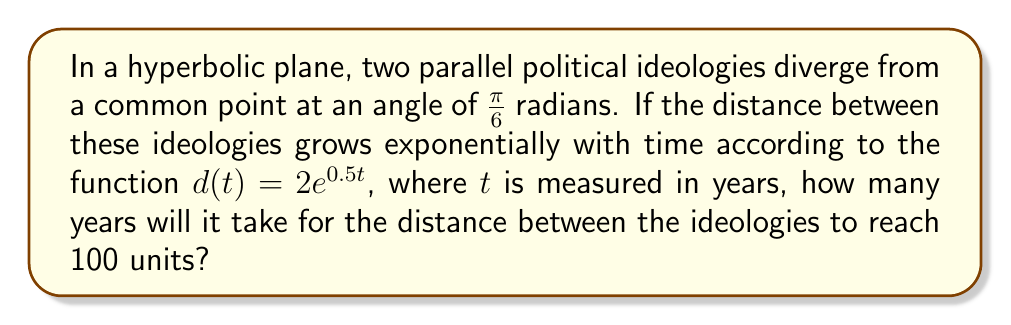Show me your answer to this math problem. Let's approach this step-by-step:

1) In hyperbolic geometry, parallel lines diverge exponentially. This aligns well with our model of diverging political ideologies.

2) We're given the distance function: $d(t) = 2e^{0.5t}$

3) We need to find $t$ when $d(t) = 100$. Let's set up the equation:

   $100 = 2e^{0.5t}$

4) Divide both sides by 2:

   $50 = e^{0.5t}$

5) Take the natural logarithm of both sides:

   $\ln(50) = \ln(e^{0.5t})$

6) Simplify the right side using the properties of logarithms:

   $\ln(50) = 0.5t$

7) Divide both sides by 0.5:

   $\frac{\ln(50)}{0.5} = t$

8) Calculate:

   $t = 2\ln(50) \approx 7.824$ years

Therefore, it will take approximately 7.824 years for the distance between the ideologies to reach 100 units.
Answer: $2\ln(50) \approx 7.824$ years 